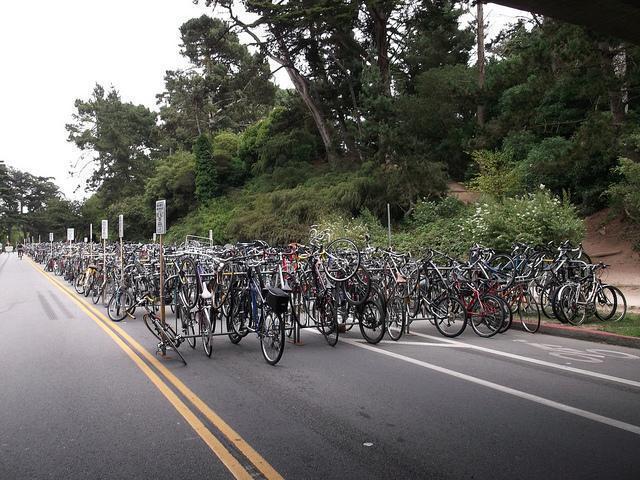What company is known for making the abundant items here?
Make your selection from the four choices given to correctly answer the question.
Options: Green giant, huffy, popeyes, mcdonalds. Huffy. 